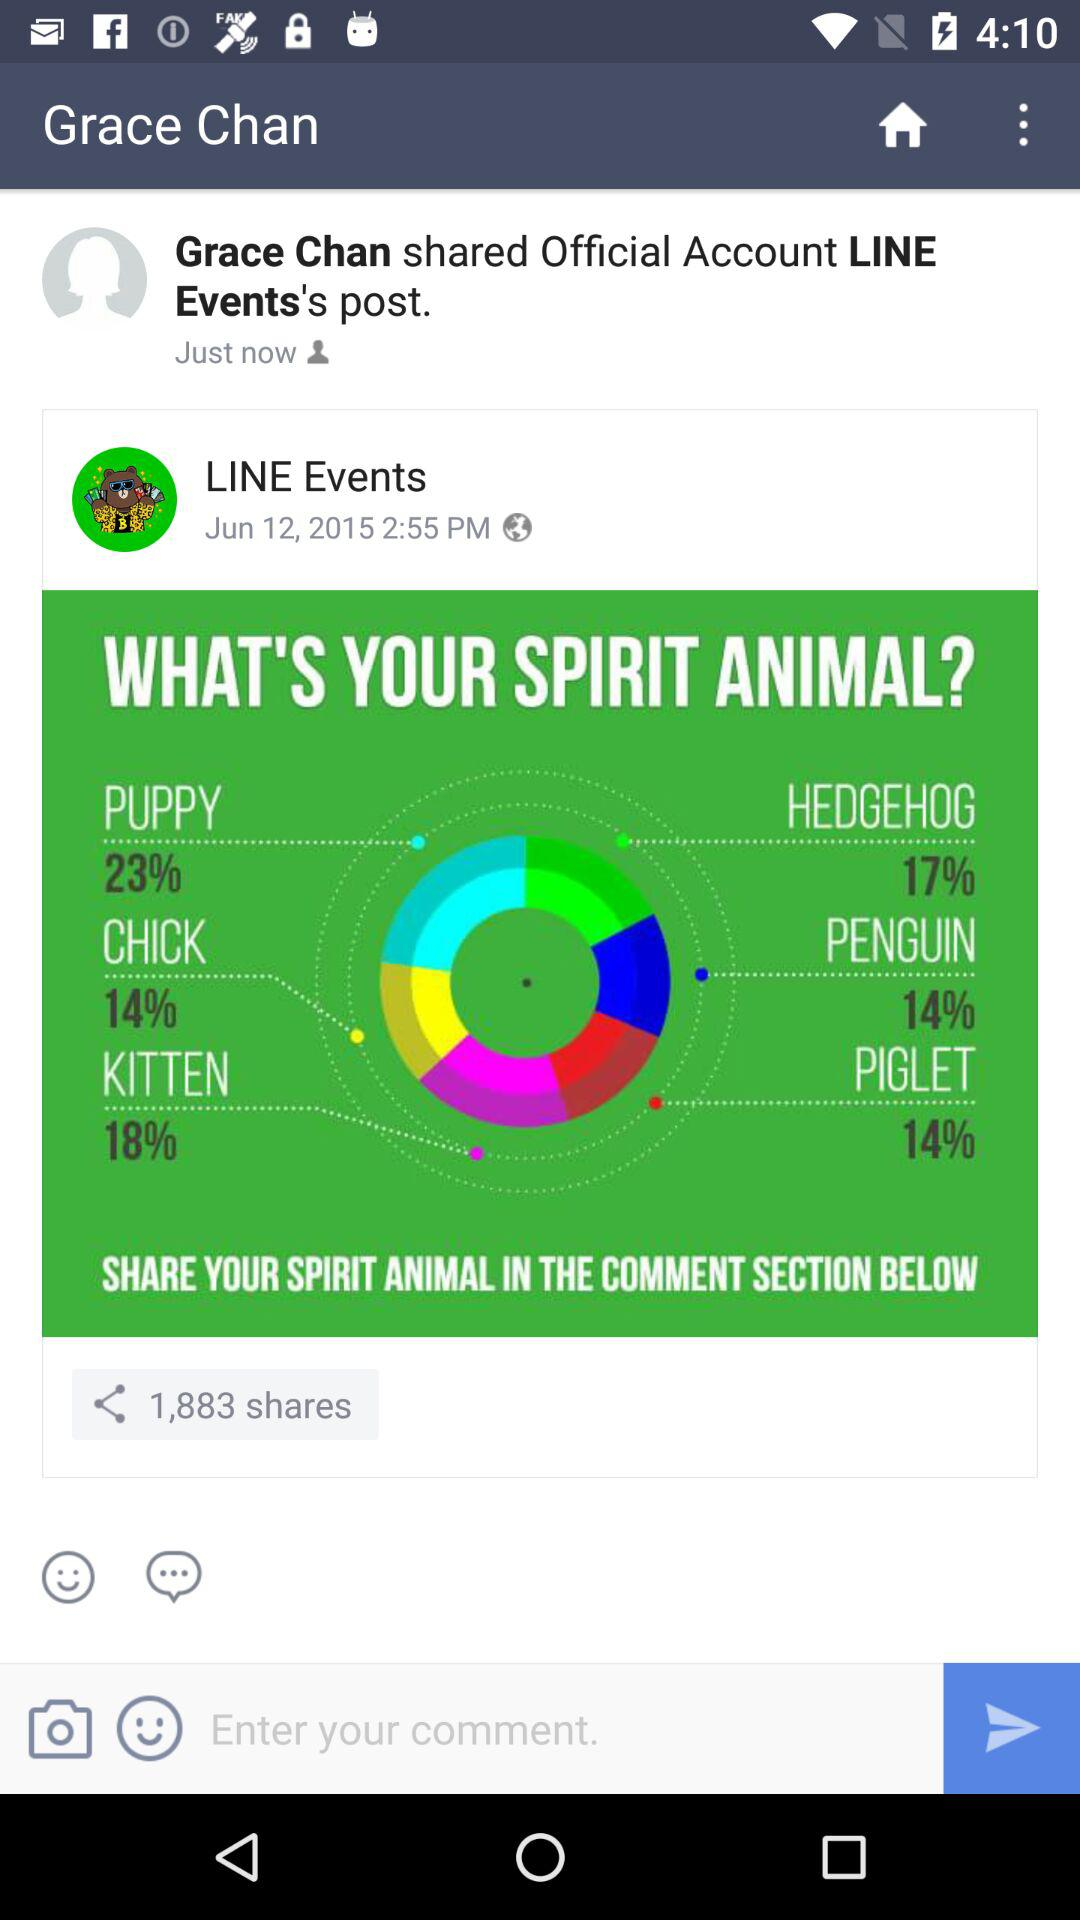What's the total number of shares for the post by "LINE Events"? The total number of shares is 1,883. 